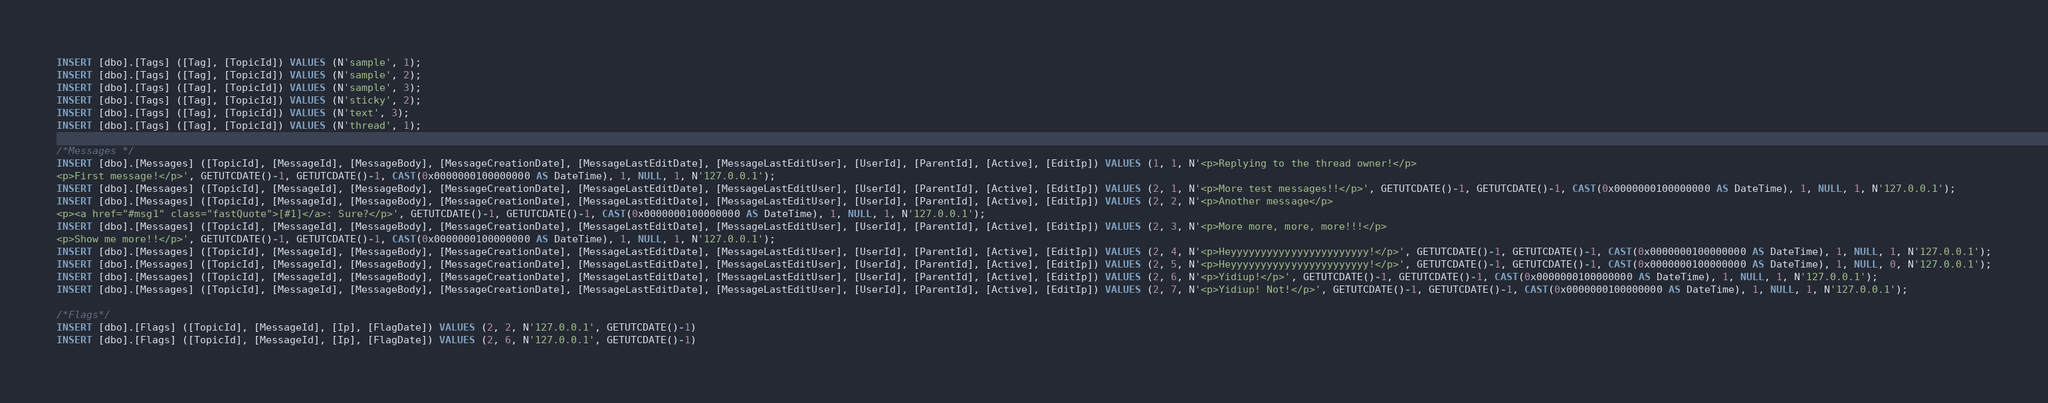Convert code to text. <code><loc_0><loc_0><loc_500><loc_500><_SQL_>INSERT [dbo].[Tags] ([Tag], [TopicId]) VALUES (N'sample', 1);
INSERT [dbo].[Tags] ([Tag], [TopicId]) VALUES (N'sample', 2);
INSERT [dbo].[Tags] ([Tag], [TopicId]) VALUES (N'sample', 3);
INSERT [dbo].[Tags] ([Tag], [TopicId]) VALUES (N'sticky', 2);
INSERT [dbo].[Tags] ([Tag], [TopicId]) VALUES (N'text', 3);
INSERT [dbo].[Tags] ([Tag], [TopicId]) VALUES (N'thread', 1);

/*Messages */
INSERT [dbo].[Messages] ([TopicId], [MessageId], [MessageBody], [MessageCreationDate], [MessageLastEditDate], [MessageLastEditUser], [UserId], [ParentId], [Active], [EditIp]) VALUES (1, 1, N'<p>Replying to the thread owner!</p>
<p>First message!</p>', GETUTCDATE()-1, GETUTCDATE()-1, CAST(0x0000000100000000 AS DateTime), 1, NULL, 1, N'127.0.0.1');
INSERT [dbo].[Messages] ([TopicId], [MessageId], [MessageBody], [MessageCreationDate], [MessageLastEditDate], [MessageLastEditUser], [UserId], [ParentId], [Active], [EditIp]) VALUES (2, 1, N'<p>More test messages!!</p>', GETUTCDATE()-1, GETUTCDATE()-1, CAST(0x0000000100000000 AS DateTime), 1, NULL, 1, N'127.0.0.1');
INSERT [dbo].[Messages] ([TopicId], [MessageId], [MessageBody], [MessageCreationDate], [MessageLastEditDate], [MessageLastEditUser], [UserId], [ParentId], [Active], [EditIp]) VALUES (2, 2, N'<p>Another message</p>
<p><a href="#msg1" class="fastQuote">[#1]</a>: Sure?</p>', GETUTCDATE()-1, GETUTCDATE()-1, CAST(0x0000000100000000 AS DateTime), 1, NULL, 1, N'127.0.0.1');
INSERT [dbo].[Messages] ([TopicId], [MessageId], [MessageBody], [MessageCreationDate], [MessageLastEditDate], [MessageLastEditUser], [UserId], [ParentId], [Active], [EditIp]) VALUES (2, 3, N'<p>More more, more, more!!!</p>
<p>Show me more!!</p>', GETUTCDATE()-1, GETUTCDATE()-1, CAST(0x0000000100000000 AS DateTime), 1, NULL, 1, N'127.0.0.1');
INSERT [dbo].[Messages] ([TopicId], [MessageId], [MessageBody], [MessageCreationDate], [MessageLastEditDate], [MessageLastEditUser], [UserId], [ParentId], [Active], [EditIp]) VALUES (2, 4, N'<p>Heyyyyyyyyyyyyyyyyyyyyyyy!</p>', GETUTCDATE()-1, GETUTCDATE()-1, CAST(0x0000000100000000 AS DateTime), 1, NULL, 1, N'127.0.0.1');
INSERT [dbo].[Messages] ([TopicId], [MessageId], [MessageBody], [MessageCreationDate], [MessageLastEditDate], [MessageLastEditUser], [UserId], [ParentId], [Active], [EditIp]) VALUES (2, 5, N'<p>Heyyyyyyyyyyyyyyyyyyyyyyy!</p>', GETUTCDATE()-1, GETUTCDATE()-1, CAST(0x0000000100000000 AS DateTime), 1, NULL, 0, N'127.0.0.1');
INSERT [dbo].[Messages] ([TopicId], [MessageId], [MessageBody], [MessageCreationDate], [MessageLastEditDate], [MessageLastEditUser], [UserId], [ParentId], [Active], [EditIp]) VALUES (2, 6, N'<p>Yidiup!</p>', GETUTCDATE()-1, GETUTCDATE()-1, CAST(0x0000000100000000 AS DateTime), 1, NULL, 1, N'127.0.0.1');
INSERT [dbo].[Messages] ([TopicId], [MessageId], [MessageBody], [MessageCreationDate], [MessageLastEditDate], [MessageLastEditUser], [UserId], [ParentId], [Active], [EditIp]) VALUES (2, 7, N'<p>Yidiup! Not!</p>', GETUTCDATE()-1, GETUTCDATE()-1, CAST(0x0000000100000000 AS DateTime), 1, NULL, 1, N'127.0.0.1');

/*Flags*/
INSERT [dbo].[Flags] ([TopicId], [MessageId], [Ip], [FlagDate]) VALUES (2, 2, N'127.0.0.1', GETUTCDATE()-1)
INSERT [dbo].[Flags] ([TopicId], [MessageId], [Ip], [FlagDate]) VALUES (2, 6, N'127.0.0.1', GETUTCDATE()-1)
</code> 